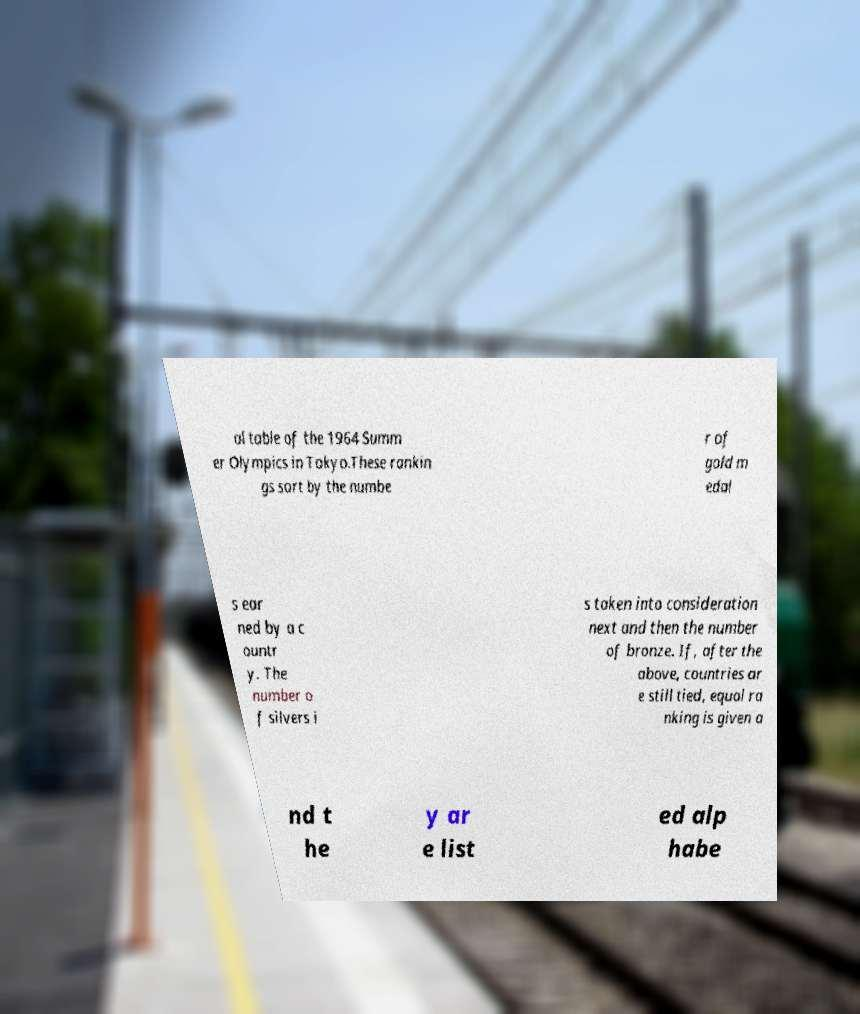For documentation purposes, I need the text within this image transcribed. Could you provide that? al table of the 1964 Summ er Olympics in Tokyo.These rankin gs sort by the numbe r of gold m edal s ear ned by a c ountr y. The number o f silvers i s taken into consideration next and then the number of bronze. If, after the above, countries ar e still tied, equal ra nking is given a nd t he y ar e list ed alp habe 